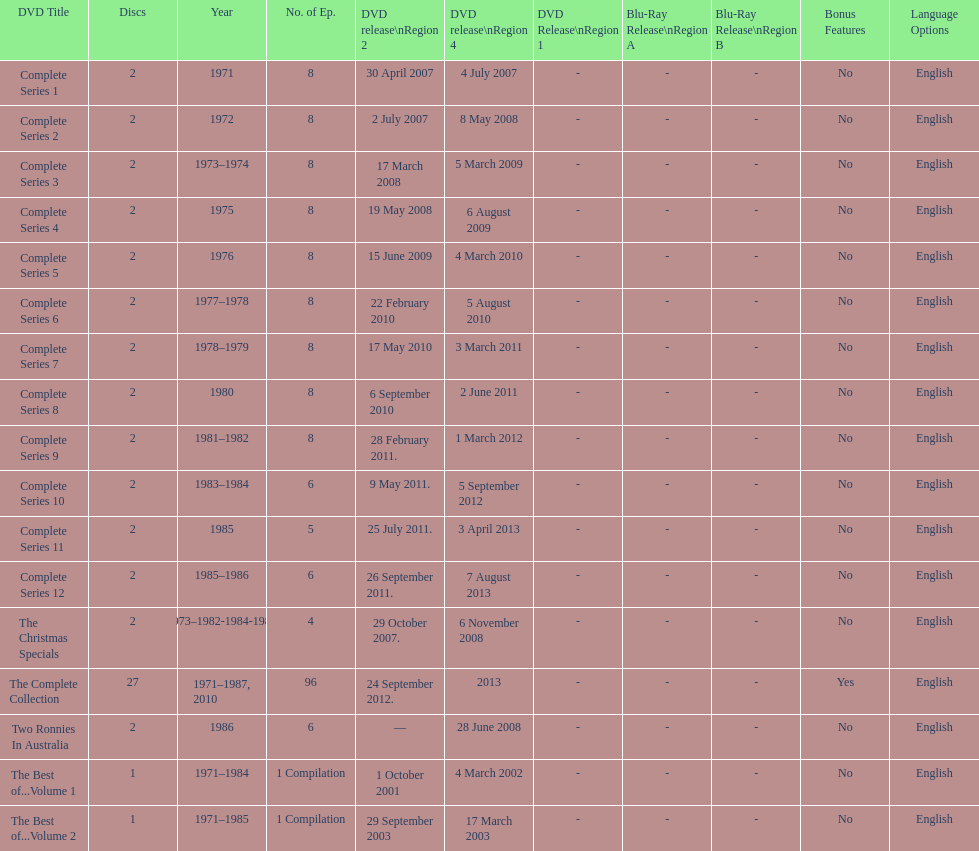Total number of episodes released in region 2 in 2007 20. 